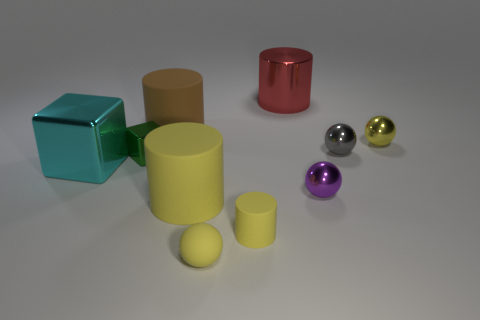The yellow shiny thing is what size?
Offer a terse response. Small. What shape is the large object that is made of the same material as the big brown cylinder?
Offer a terse response. Cylinder. Is the number of tiny things to the left of the green thing less than the number of rubber cylinders?
Make the answer very short. Yes. There is a big shiny thing that is to the left of the green block; what is its color?
Offer a terse response. Cyan. What is the material of the other ball that is the same color as the tiny matte sphere?
Your answer should be compact. Metal. Are there any tiny yellow matte things of the same shape as the small yellow shiny object?
Provide a succinct answer. Yes. How many small green shiny objects are the same shape as the big cyan object?
Make the answer very short. 1. Does the rubber ball have the same color as the small matte cylinder?
Keep it short and to the point. Yes. Are there fewer tiny gray balls than yellow rubber objects?
Provide a succinct answer. Yes. What material is the tiny yellow sphere behind the gray shiny ball?
Offer a very short reply. Metal. 